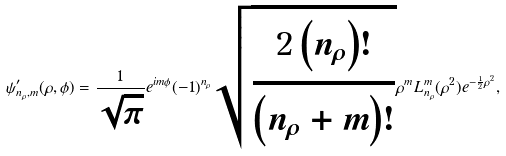<formula> <loc_0><loc_0><loc_500><loc_500>\psi ^ { \prime } _ { n _ { \rho } , m } ( \rho , \phi ) = \frac { 1 } { \sqrt { \pi } } e ^ { i m \phi } ( - 1 ) ^ { n _ { \rho } } \sqrt { \frac { 2 \left ( n _ { \rho } \right ) ! } { \left ( n _ { \rho } + m \right ) ! } } \rho ^ { m } L _ { n _ { \rho } } ^ { m } ( \rho ^ { 2 } ) e ^ { - \frac { 1 } { 2 } \rho ^ { 2 } } ,</formula> 